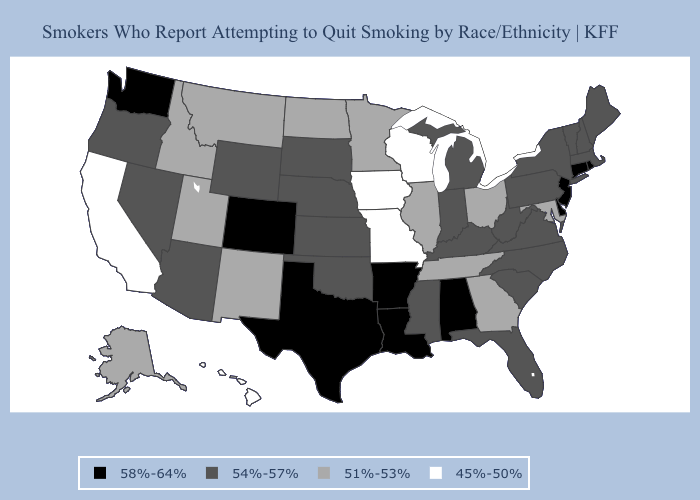What is the value of Missouri?
Be succinct. 45%-50%. Does Illinois have a higher value than Texas?
Answer briefly. No. Which states have the lowest value in the USA?
Short answer required. California, Hawaii, Iowa, Missouri, Wisconsin. Does Nebraska have the same value as Wyoming?
Quick response, please. Yes. How many symbols are there in the legend?
Give a very brief answer. 4. Name the states that have a value in the range 58%-64%?
Concise answer only. Alabama, Arkansas, Colorado, Connecticut, Delaware, Louisiana, New Jersey, Rhode Island, Texas, Washington. What is the value of Colorado?
Concise answer only. 58%-64%. Among the states that border Mississippi , does Tennessee have the lowest value?
Write a very short answer. Yes. Name the states that have a value in the range 45%-50%?
Be succinct. California, Hawaii, Iowa, Missouri, Wisconsin. Among the states that border Nebraska , which have the lowest value?
Be succinct. Iowa, Missouri. What is the value of Kentucky?
Answer briefly. 54%-57%. Does the first symbol in the legend represent the smallest category?
Write a very short answer. No. Does Minnesota have the highest value in the MidWest?
Keep it brief. No. Does Maryland have a lower value than Iowa?
Write a very short answer. No. Name the states that have a value in the range 54%-57%?
Keep it brief. Arizona, Florida, Indiana, Kansas, Kentucky, Maine, Massachusetts, Michigan, Mississippi, Nebraska, Nevada, New Hampshire, New York, North Carolina, Oklahoma, Oregon, Pennsylvania, South Carolina, South Dakota, Vermont, Virginia, West Virginia, Wyoming. 